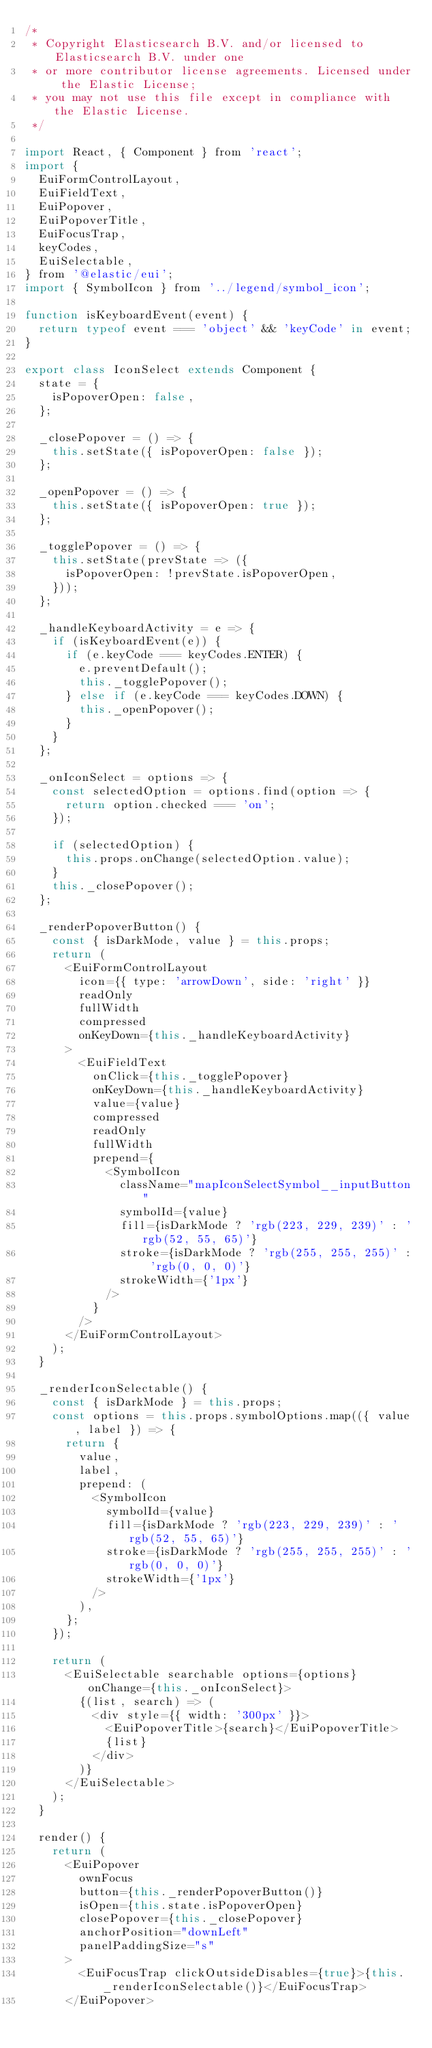<code> <loc_0><loc_0><loc_500><loc_500><_JavaScript_>/*
 * Copyright Elasticsearch B.V. and/or licensed to Elasticsearch B.V. under one
 * or more contributor license agreements. Licensed under the Elastic License;
 * you may not use this file except in compliance with the Elastic License.
 */

import React, { Component } from 'react';
import {
  EuiFormControlLayout,
  EuiFieldText,
  EuiPopover,
  EuiPopoverTitle,
  EuiFocusTrap,
  keyCodes,
  EuiSelectable,
} from '@elastic/eui';
import { SymbolIcon } from '../legend/symbol_icon';

function isKeyboardEvent(event) {
  return typeof event === 'object' && 'keyCode' in event;
}

export class IconSelect extends Component {
  state = {
    isPopoverOpen: false,
  };

  _closePopover = () => {
    this.setState({ isPopoverOpen: false });
  };

  _openPopover = () => {
    this.setState({ isPopoverOpen: true });
  };

  _togglePopover = () => {
    this.setState(prevState => ({
      isPopoverOpen: !prevState.isPopoverOpen,
    }));
  };

  _handleKeyboardActivity = e => {
    if (isKeyboardEvent(e)) {
      if (e.keyCode === keyCodes.ENTER) {
        e.preventDefault();
        this._togglePopover();
      } else if (e.keyCode === keyCodes.DOWN) {
        this._openPopover();
      }
    }
  };

  _onIconSelect = options => {
    const selectedOption = options.find(option => {
      return option.checked === 'on';
    });

    if (selectedOption) {
      this.props.onChange(selectedOption.value);
    }
    this._closePopover();
  };

  _renderPopoverButton() {
    const { isDarkMode, value } = this.props;
    return (
      <EuiFormControlLayout
        icon={{ type: 'arrowDown', side: 'right' }}
        readOnly
        fullWidth
        compressed
        onKeyDown={this._handleKeyboardActivity}
      >
        <EuiFieldText
          onClick={this._togglePopover}
          onKeyDown={this._handleKeyboardActivity}
          value={value}
          compressed
          readOnly
          fullWidth
          prepend={
            <SymbolIcon
              className="mapIconSelectSymbol__inputButton"
              symbolId={value}
              fill={isDarkMode ? 'rgb(223, 229, 239)' : 'rgb(52, 55, 65)'}
              stroke={isDarkMode ? 'rgb(255, 255, 255)' : 'rgb(0, 0, 0)'}
              strokeWidth={'1px'}
            />
          }
        />
      </EuiFormControlLayout>
    );
  }

  _renderIconSelectable() {
    const { isDarkMode } = this.props;
    const options = this.props.symbolOptions.map(({ value, label }) => {
      return {
        value,
        label,
        prepend: (
          <SymbolIcon
            symbolId={value}
            fill={isDarkMode ? 'rgb(223, 229, 239)' : 'rgb(52, 55, 65)'}
            stroke={isDarkMode ? 'rgb(255, 255, 255)' : 'rgb(0, 0, 0)'}
            strokeWidth={'1px'}
          />
        ),
      };
    });

    return (
      <EuiSelectable searchable options={options} onChange={this._onIconSelect}>
        {(list, search) => (
          <div style={{ width: '300px' }}>
            <EuiPopoverTitle>{search}</EuiPopoverTitle>
            {list}
          </div>
        )}
      </EuiSelectable>
    );
  }

  render() {
    return (
      <EuiPopover
        ownFocus
        button={this._renderPopoverButton()}
        isOpen={this.state.isPopoverOpen}
        closePopover={this._closePopover}
        anchorPosition="downLeft"
        panelPaddingSize="s"
      >
        <EuiFocusTrap clickOutsideDisables={true}>{this._renderIconSelectable()}</EuiFocusTrap>
      </EuiPopover></code> 